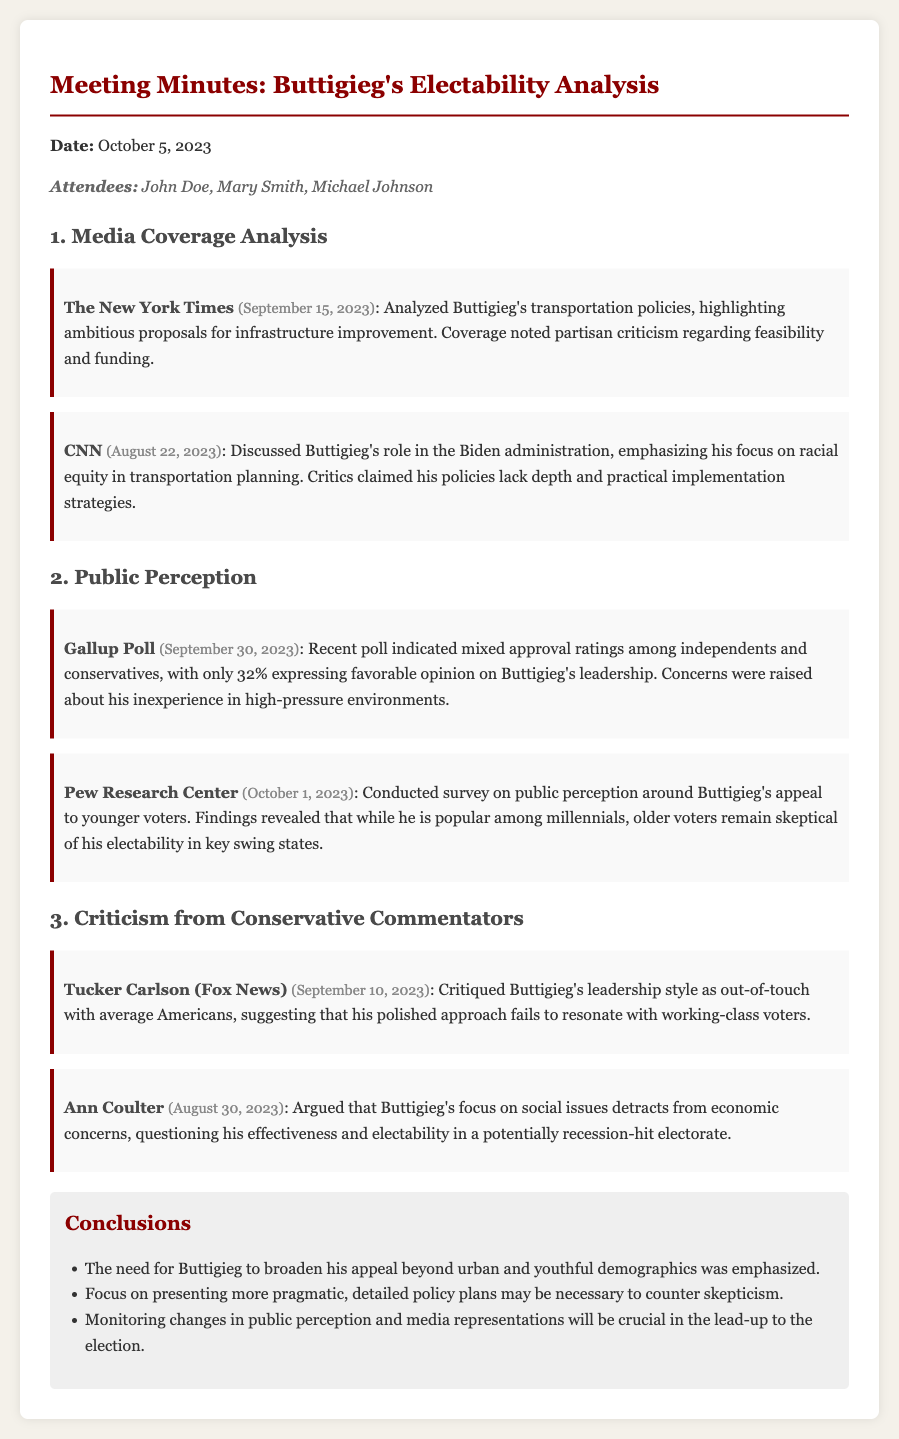What date was the meeting held? The date of the meeting is mentioned at the top of the document.
Answer: October 5, 2023 Who analyzed Buttigieg's transportation policies? The document specifies a source that analyzed Buttigieg's transportation policies.
Answer: The New York Times What percentage of people had a favorable opinion of Buttigieg according to Gallup Poll? The document provides a statistic from a Gallup Poll regarding approval ratings.
Answer: 32% What was a main criticism from Tucker Carlson about Buttigieg? The document outlines criticism from Tucker Carlson specifically regarding Buttigieg's leadership style.
Answer: Out-of-touch Which demographic is Buttigieg popular among, according to the Pew Research Center? The document refers to a survey revealing different demographics and their perception of Buttigieg.
Answer: Millennials What was one conclusion drawn regarding Buttigieg's appeal? The conclusions section includes insights about Buttigieg's appeal.
Answer: Broaden his appeal What type of policies did Ann Coulter suggest Buttigieg should focus on? The document notes specific criticisms about Buttigieg's focus on social issues instead of something else.
Answer: Economic concerns Which media outlet discussed Buttigieg's focus on racial equity? The document points out a specific media outlet discussing Buttigieg's policies.
Answer: CNN 